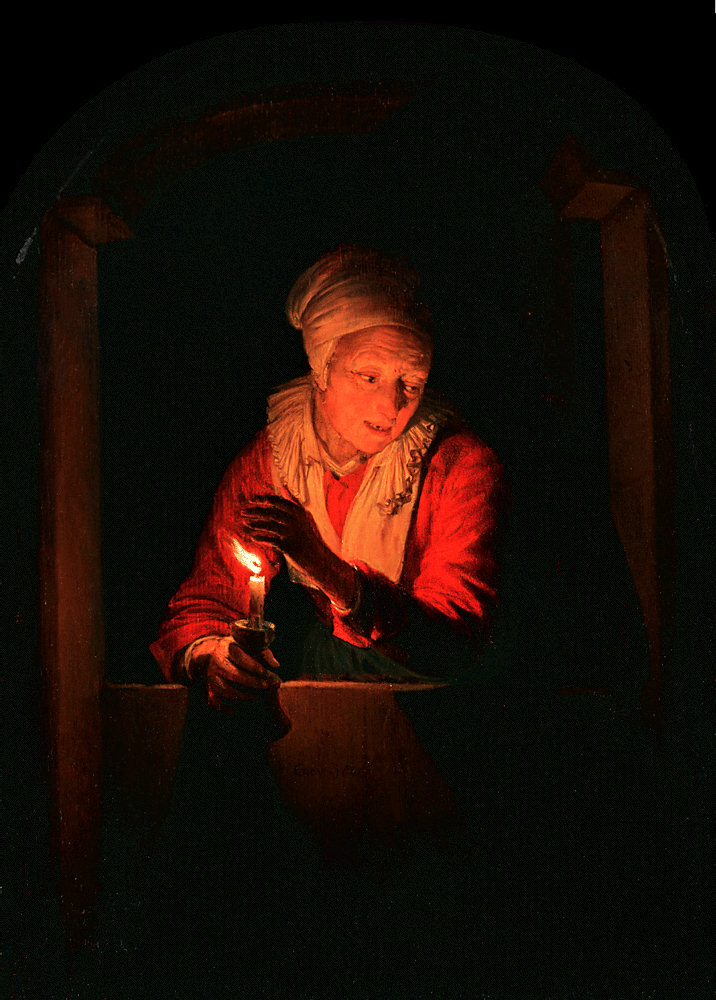If this painting could speak, what story would it tell us? If this painting could speak, it would tell the heartfelt story of Elda, an elderly woman who nightly lights a candle at her window, a beacon that symbolizes her eternal hope and enduring spirit. She would speak of love and loss, of countless nights spent in quiet reflection, and of the enduring power of light to pierce through the darkest of times. This tale would be one of resilience, warmth, and the unyielding belief that every night gives way to a new dawn. 